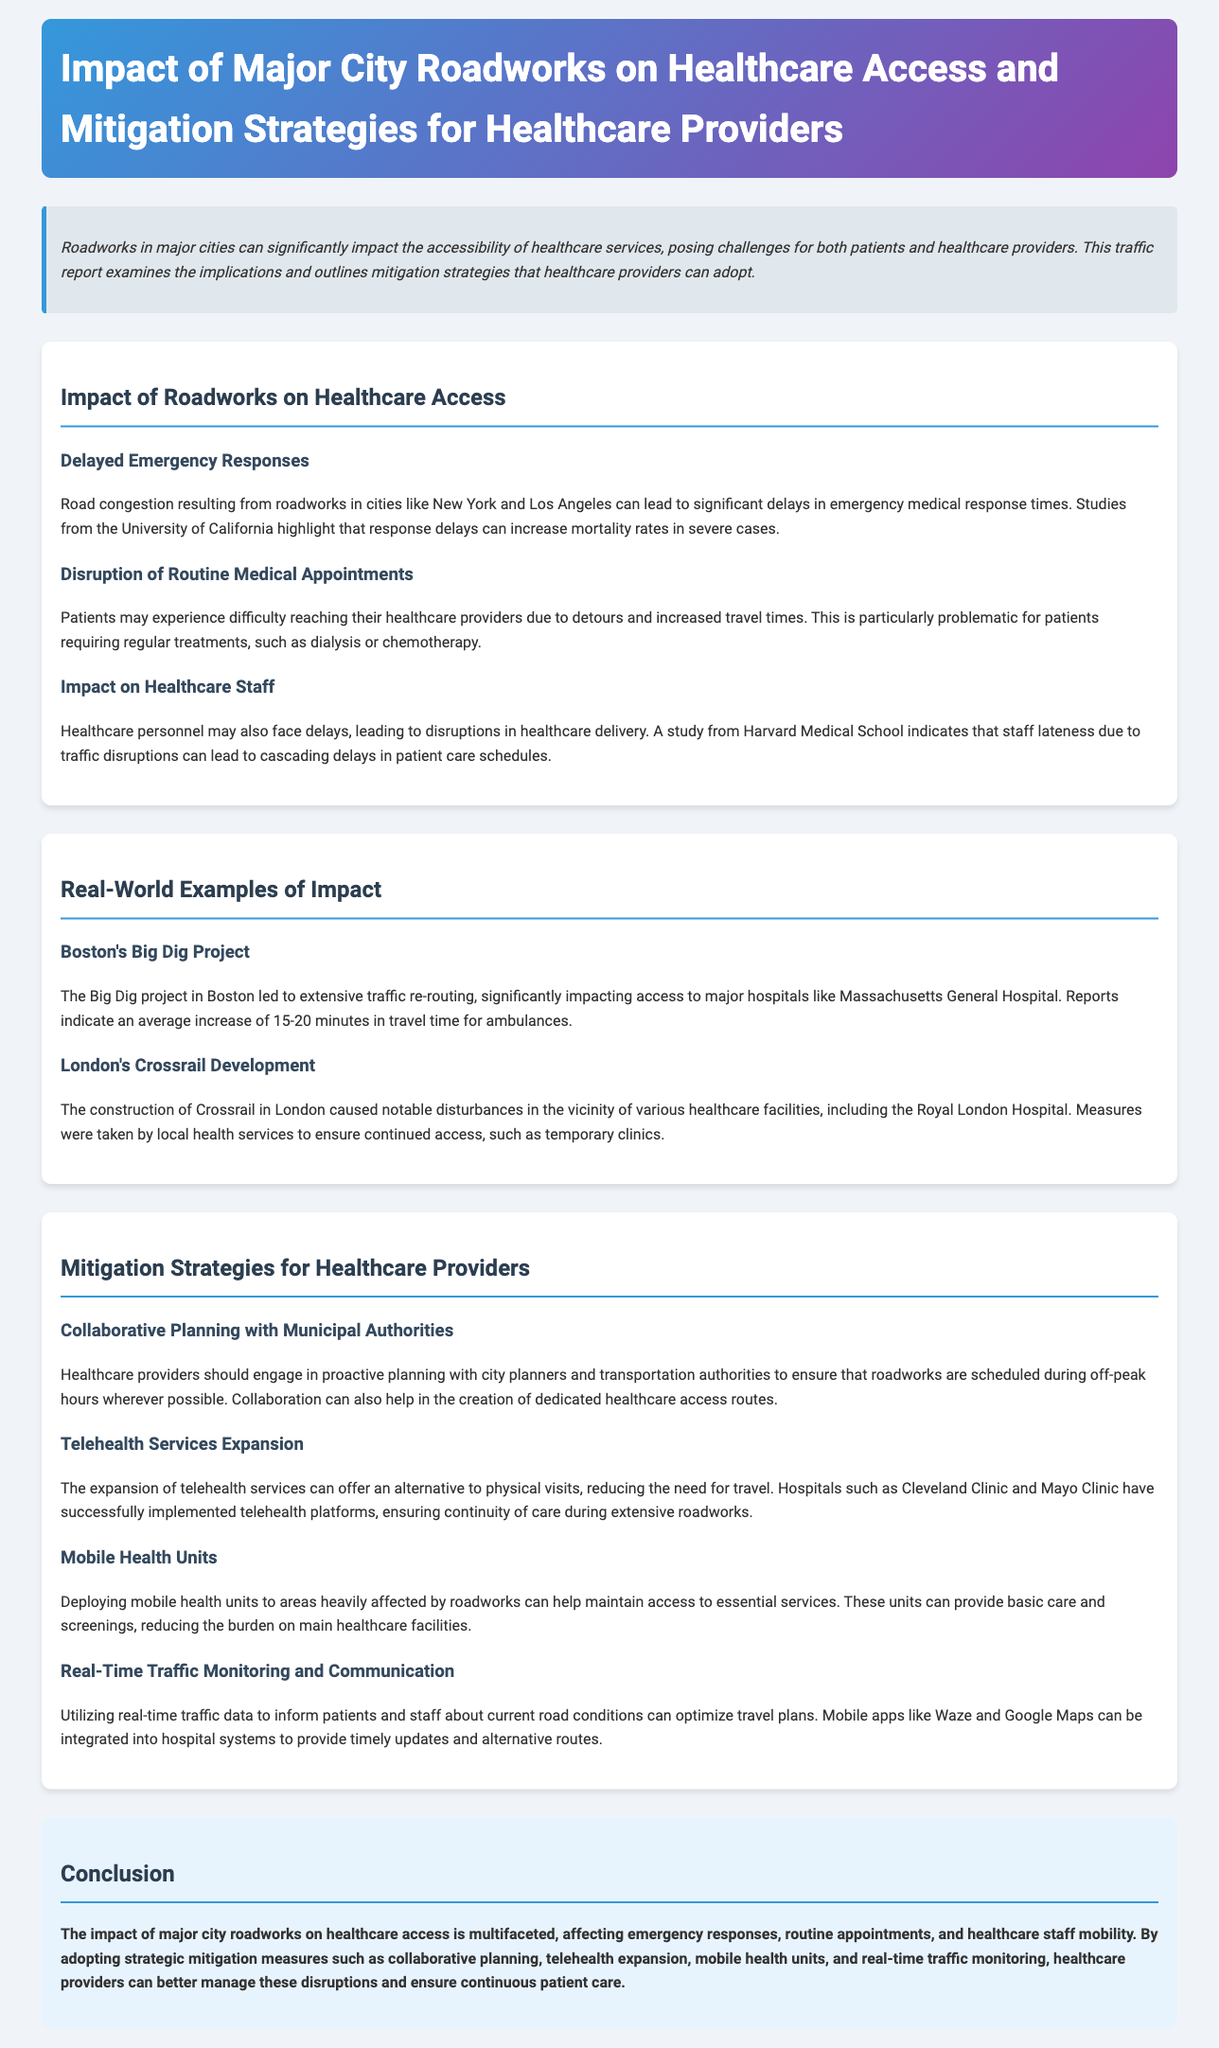What is the title of the report? The title of the report provides the main topic of the document, which is about roadworks and healthcare access in major cities.
Answer: Impact of Major City Roadworks on Healthcare Access and Mitigation Strategies for Healthcare Providers What is one consequence of delayed emergency responses? The report states that response delays can increase mortality rates in severe cases.
Answer: Increased mortality rates Which major project in Boston affected hospital access? This question tests knowledge of a specific real-world example mentioned in the document.
Answer: Big Dig project What is a mitigation strategy involving city planners? The report mentions proactive planning as a strategy, particularly in collaboration with city planners.
Answer: Collaborative Planning with Municipal Authorities How much additional travel time was reported for ambulances during the Big Dig project? The report specifies the average increase in travel time for ambulances during this project.
Answer: 15-20 minutes Which healthcare provider implemented telehealth platforms? This question addresses the implementation of telehealth services mentioned in the mitigation strategies section.
Answer: Cleveland Clinic and Mayo Clinic What is a strategy to inform patients about traffic conditions? This question aims to extract a specific tactic mentioned for improving access during roadworks.
Answer: Real-Time Traffic Monitoring and Communication What type of healthcare service can mobile health units provide? This question requires understanding of the role of mobile health units mentioned in the mitigation strategies.
Answer: Basic care and screenings 